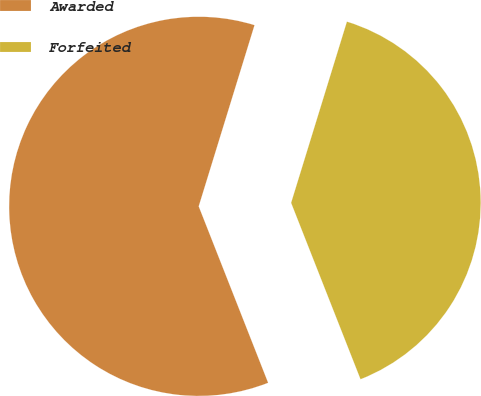Convert chart. <chart><loc_0><loc_0><loc_500><loc_500><pie_chart><fcel>Awarded<fcel>Forfeited<nl><fcel>60.72%<fcel>39.28%<nl></chart> 